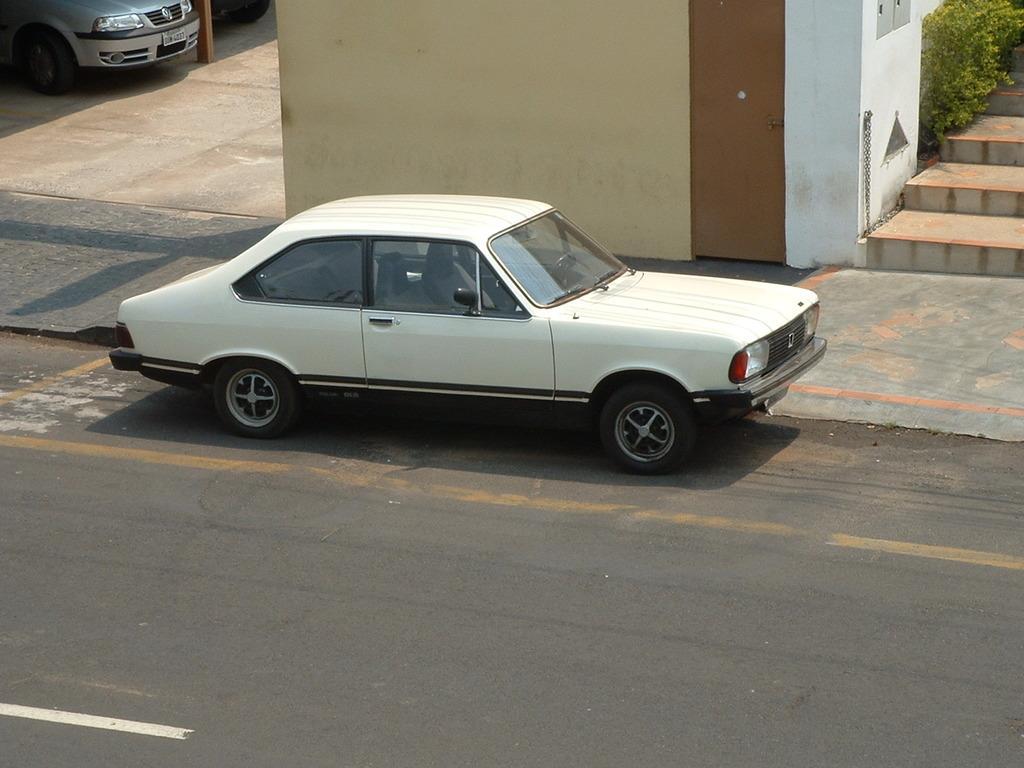Describe this image in one or two sentences. Here we can see vehicles, wall, steps and plants. This car is on the road. 